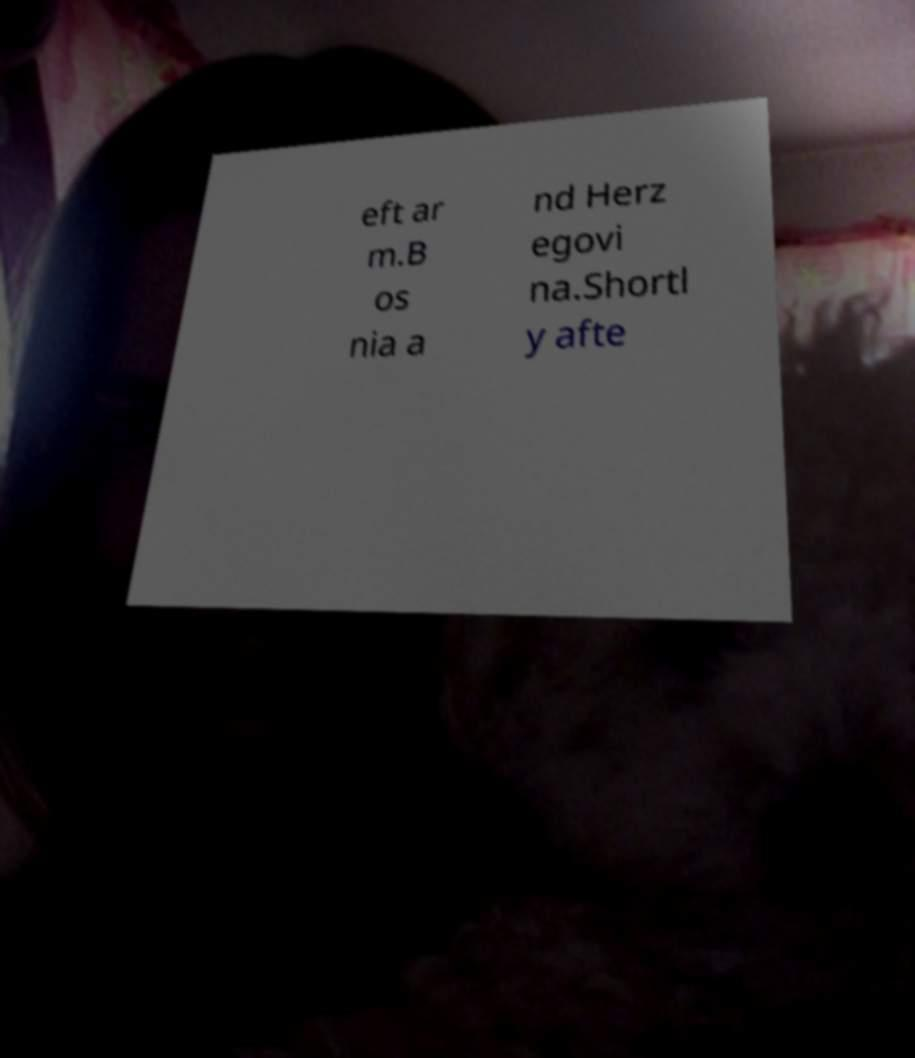Please read and relay the text visible in this image. What does it say? eft ar m.B os nia a nd Herz egovi na.Shortl y afte 